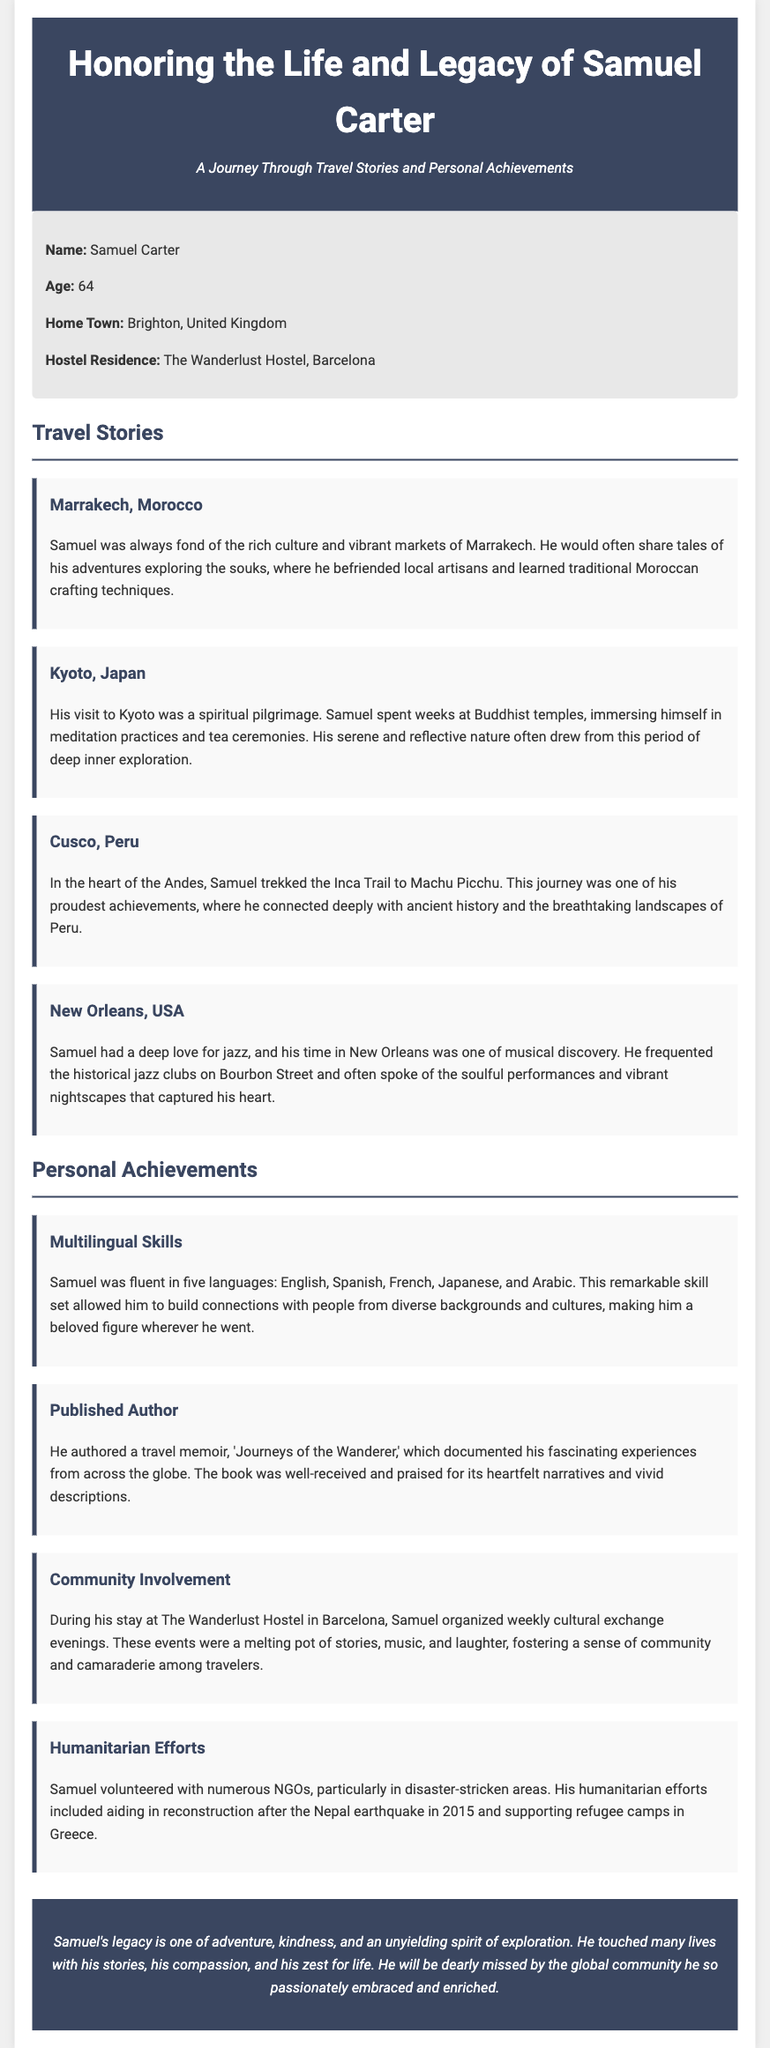What was Samuel Carter's age? The age of Samuel Carter, as mentioned in the document, is explicitly stated.
Answer: 64 Where was Samuel Carter's hometown? The document provides specific information about Samuel's hometown.
Answer: Brighton, United Kingdom What is the name of the hostel where Samuel resided? The document mentions the name of the hostel where Samuel lived during his time in Barcelona.
Answer: The Wanderlust Hostel, Barcelona What was one of Samuel's proudest travel achievements? The document describes one of Samuel's notable experiences during his travels as a proud achievement.
Answer: Trekking the Inca Trail to Machu Picchu How many languages was Samuel fluent in? The document highlights Samuel's remarkable linguistic abilities, providing a specific number.
Answer: Five What was the title of Samuel Carter's travel memoir? The document states the title of the book authored by Samuel, which is a significant part of his achievements.
Answer: Journeys of the Wanderer What type of events did Samuel organize at the hostel? The document details the nature of the activities that Samuel arranged for the community at the hostel.
Answer: Cultural exchange evenings What humanitarian effort did Samuel participate in after an earthquake? The document specifies which disaster-related humanitarian project Samuel was involved in post-earthquake.
Answer: Nepal earthquake in 2015 What theme is emphasized in Samuel's legacy? The document concludes with a statement about the overall theme of Samuel’s life and influence.
Answer: Adventure, kindness, and unyielding spirit of exploration 